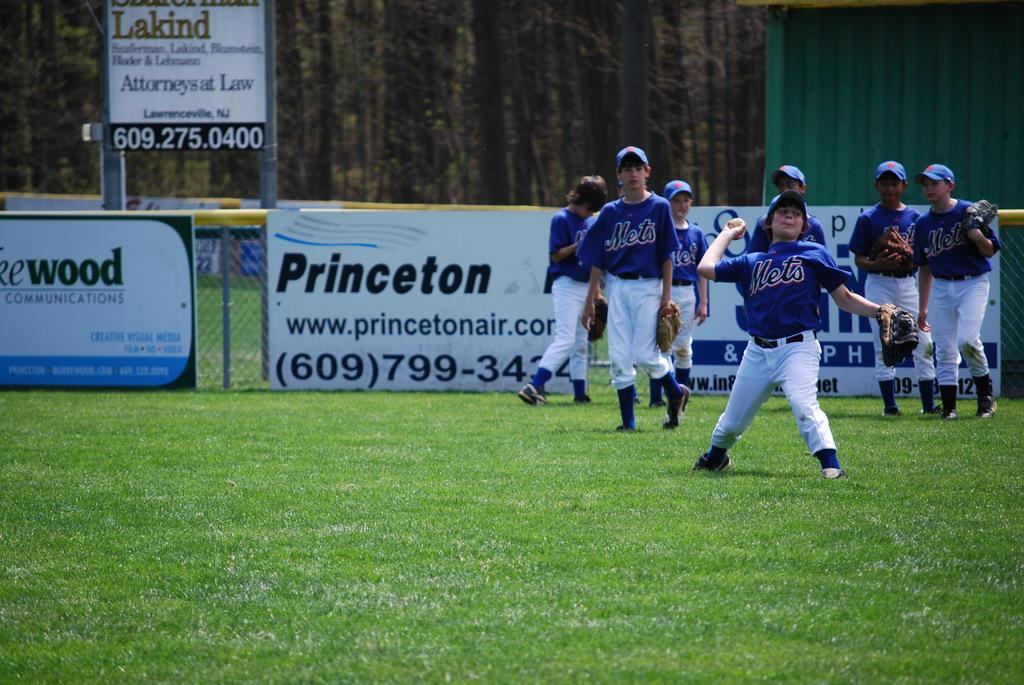<image>
Relay a brief, clear account of the picture shown. The Mets little league team warms up in front of Princeton Air sign. 